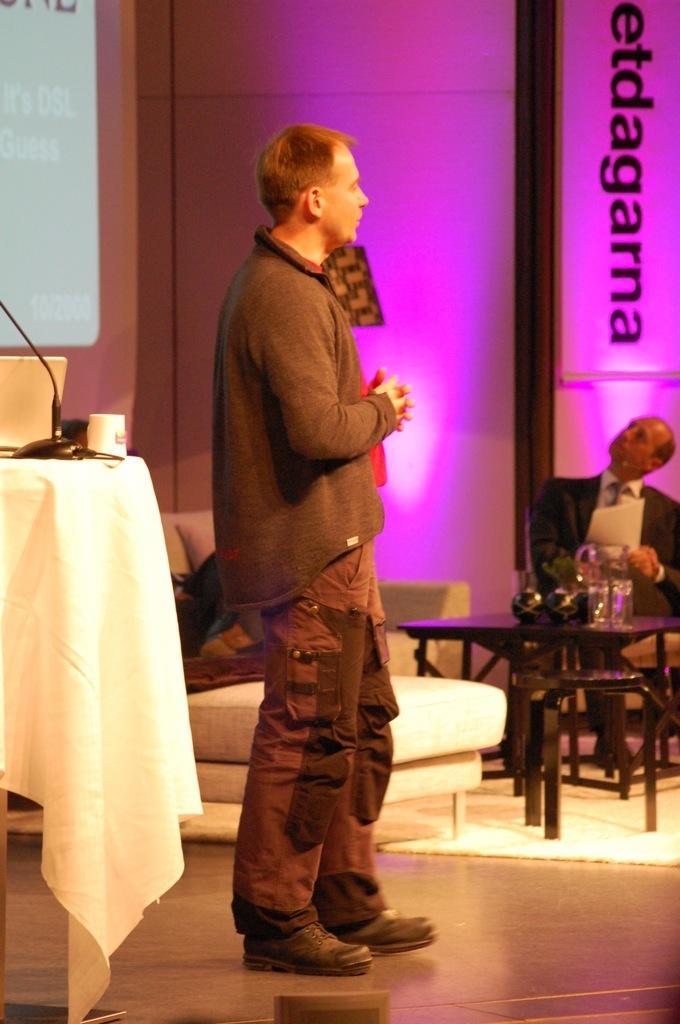In one or two sentences, can you explain what this image depicts? In the image a man is standing behind him there is a couch. Bottom right side of the image a man is sitting on a chair. In front of him there is a table on the table there is a flower pot and there are some glasses on the table. Bottom left side of the image there is a table on the table there is a laptop and cup and microphone. Top left side of the image there is a screen. Top right side of the image there is a wall. 